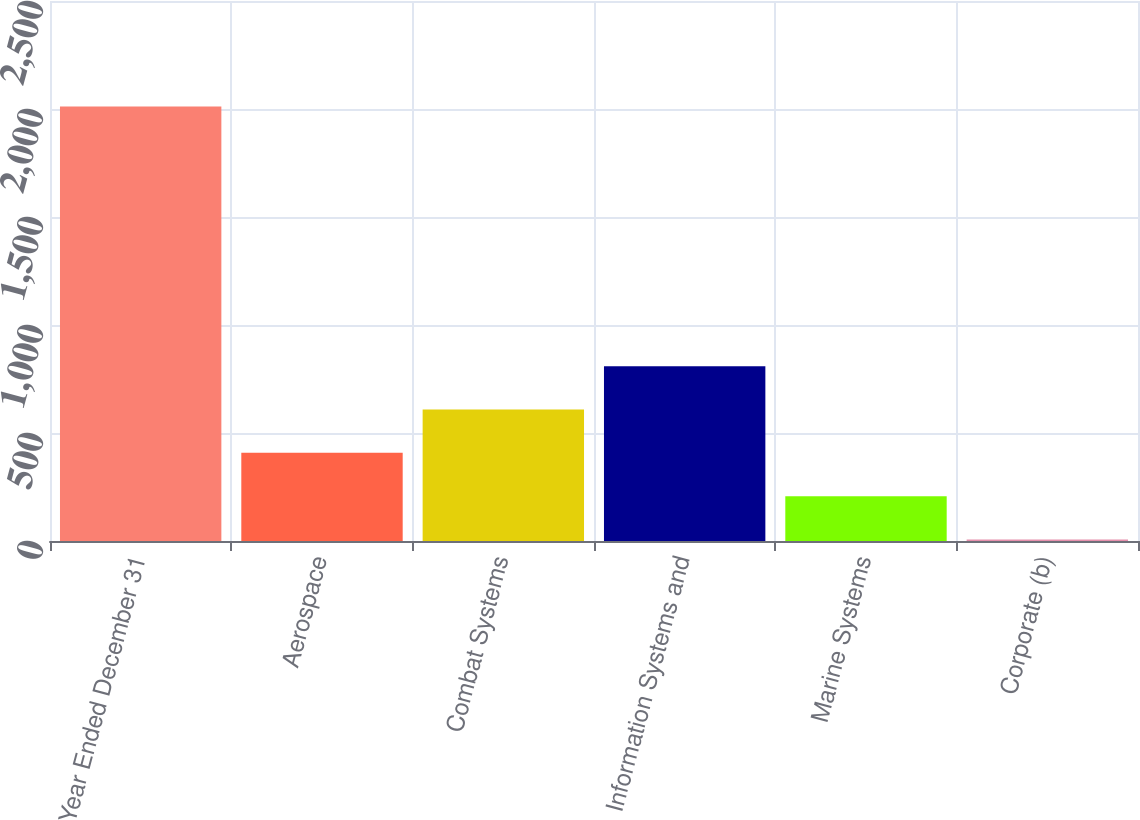Convert chart. <chart><loc_0><loc_0><loc_500><loc_500><bar_chart><fcel>Year Ended December 31<fcel>Aerospace<fcel>Combat Systems<fcel>Information Systems and<fcel>Marine Systems<fcel>Corporate (b)<nl><fcel>2012<fcel>408<fcel>608.5<fcel>809<fcel>207.5<fcel>7<nl></chart> 